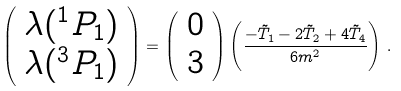Convert formula to latex. <formula><loc_0><loc_0><loc_500><loc_500>\left ( \begin{array} { c } { { \lambda ( ^ { 1 } P _ { 1 } ) } } \\ { { \lambda ( ^ { 3 } P _ { 1 } ) } } \end{array} \right ) = \left ( \begin{array} { c } { 0 } \\ { 3 } \end{array} \right ) \left ( \frac { - \tilde { T } _ { 1 } - 2 \tilde { T } _ { 2 } + 4 \tilde { T } _ { 4 } } { 6 m ^ { 2 } } \right ) \, .</formula> 